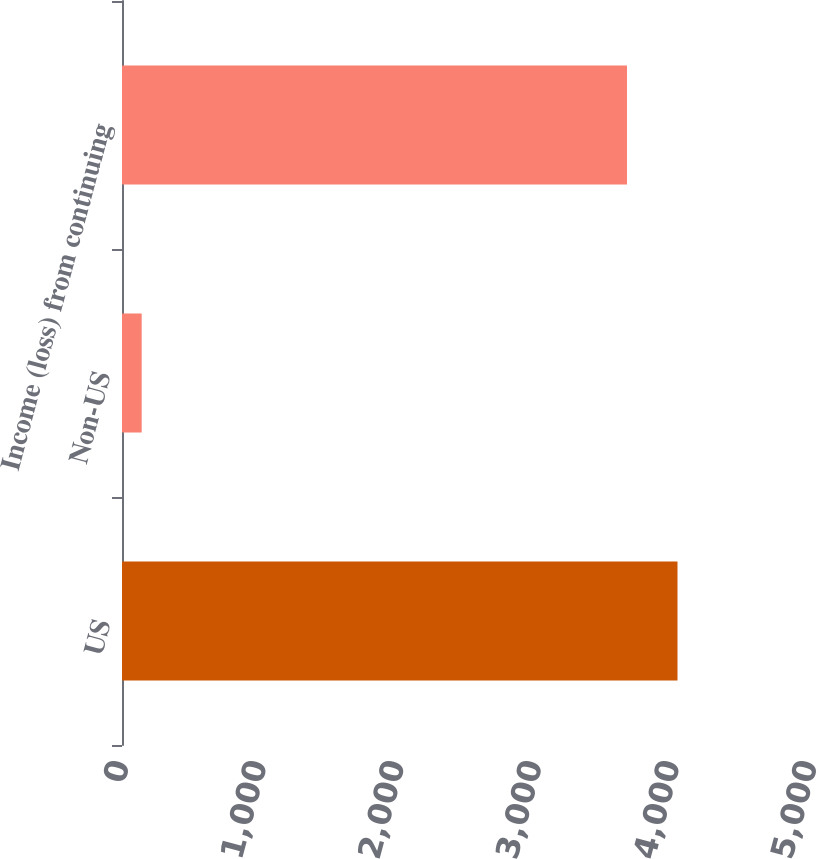Convert chart. <chart><loc_0><loc_0><loc_500><loc_500><bar_chart><fcel>US<fcel>Non-US<fcel>Income (loss) from continuing<nl><fcel>4037<fcel>143<fcel>3670<nl></chart> 